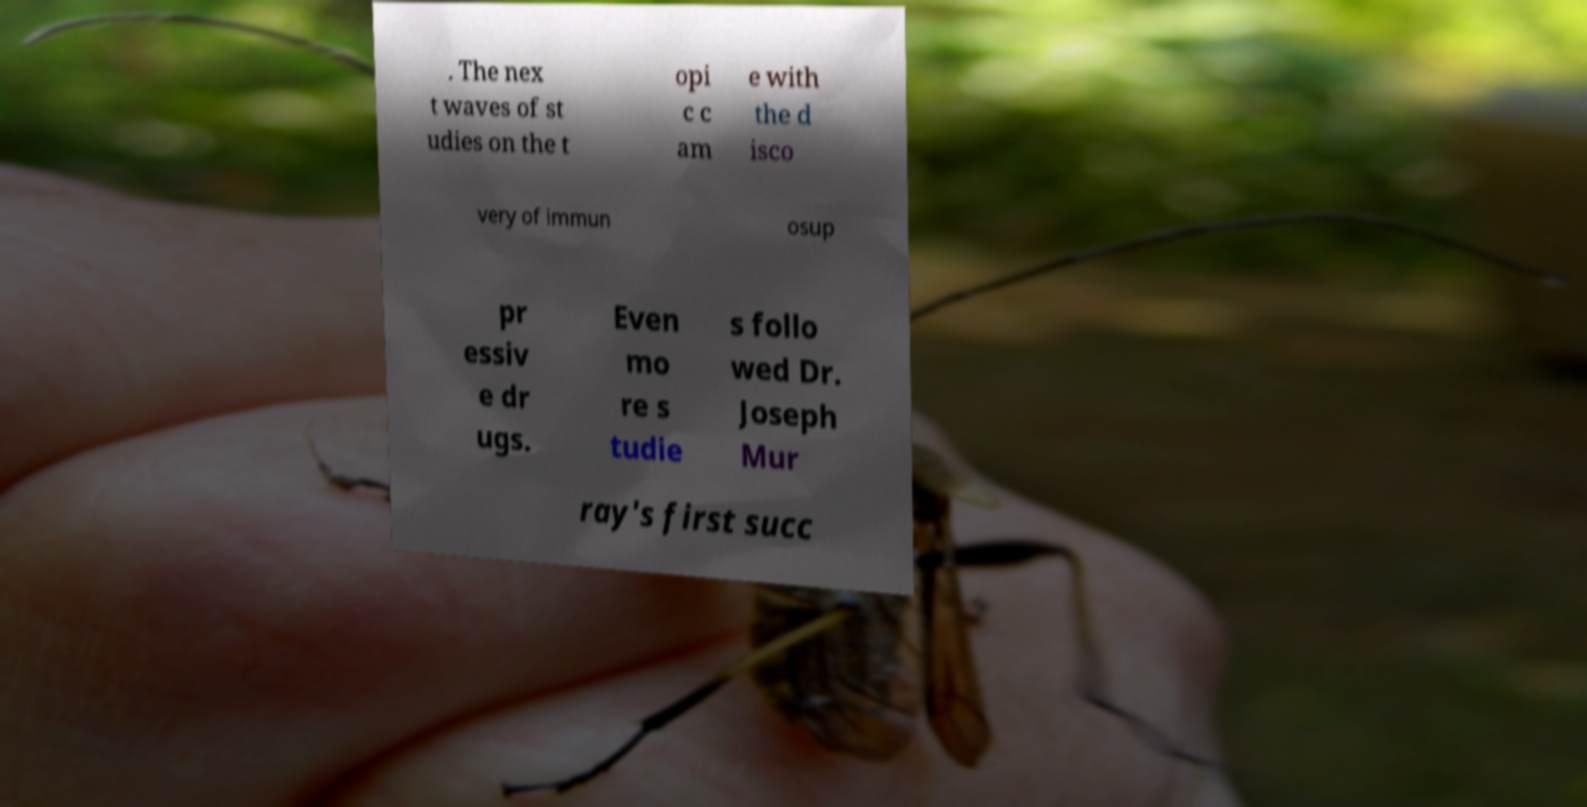There's text embedded in this image that I need extracted. Can you transcribe it verbatim? . The nex t waves of st udies on the t opi c c am e with the d isco very of immun osup pr essiv e dr ugs. Even mo re s tudie s follo wed Dr. Joseph Mur ray's first succ 